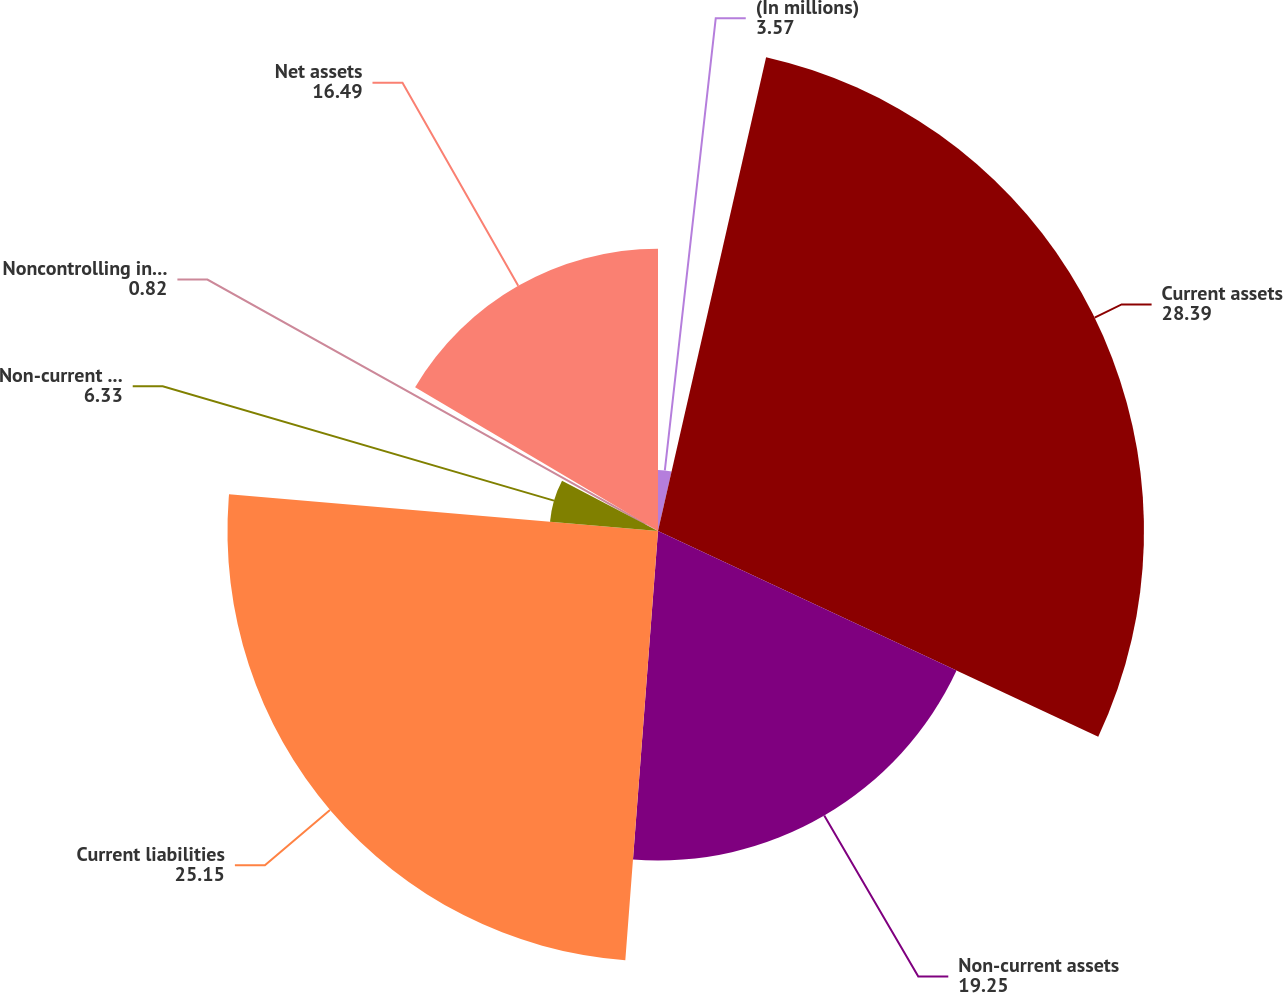Convert chart to OTSL. <chart><loc_0><loc_0><loc_500><loc_500><pie_chart><fcel>(In millions)<fcel>Current assets<fcel>Non-current assets<fcel>Current liabilities<fcel>Non-current liabilities<fcel>Noncontrolling interests<fcel>Net assets<nl><fcel>3.57%<fcel>28.39%<fcel>19.25%<fcel>25.15%<fcel>6.33%<fcel>0.82%<fcel>16.49%<nl></chart> 